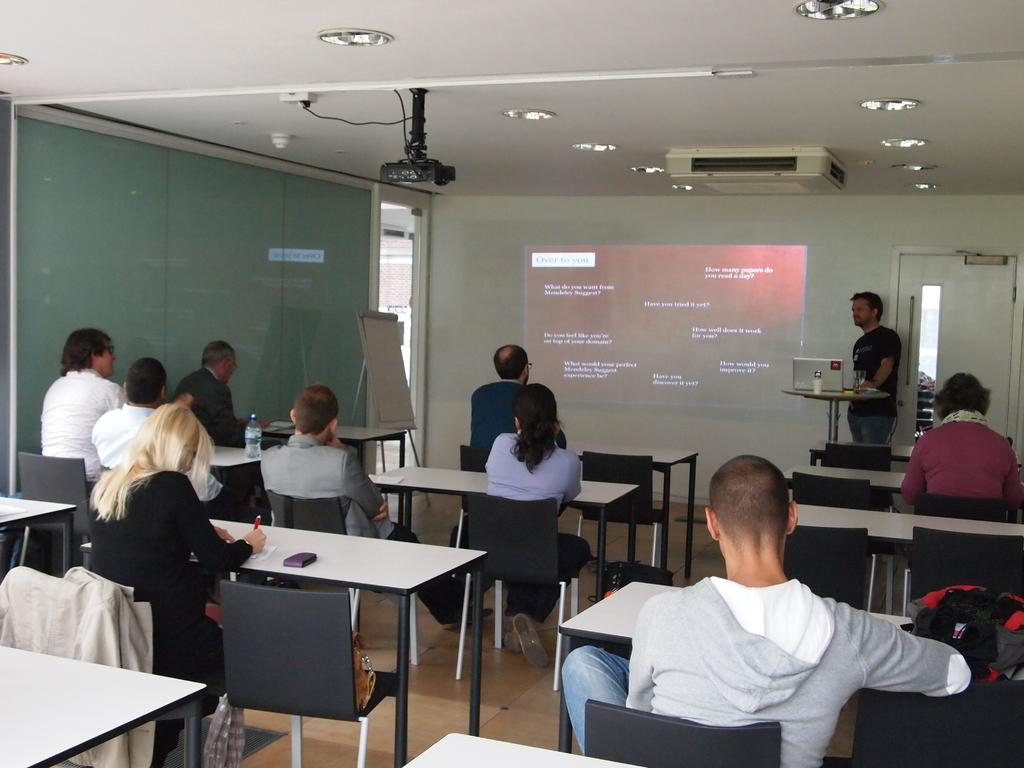What are the people in the image doing? The people in the image are sitting on chairs. What is in front of the chairs? There is a table in front of the chairs. Can you describe the background of the image? In the background, there is a man standing, a laptop, a projector, and a board. What might the people sitting on chairs be using the table for? They might be using the table for writing, eating, or placing their belongings. What is the purpose of the board in the background? The board in the background might be used for displaying information, writing notes, or presenting ideas. How does the observation guide the support in the image? There is no mention of observation or support in the image; it features people sitting on chairs, a table, and objects in the background. 